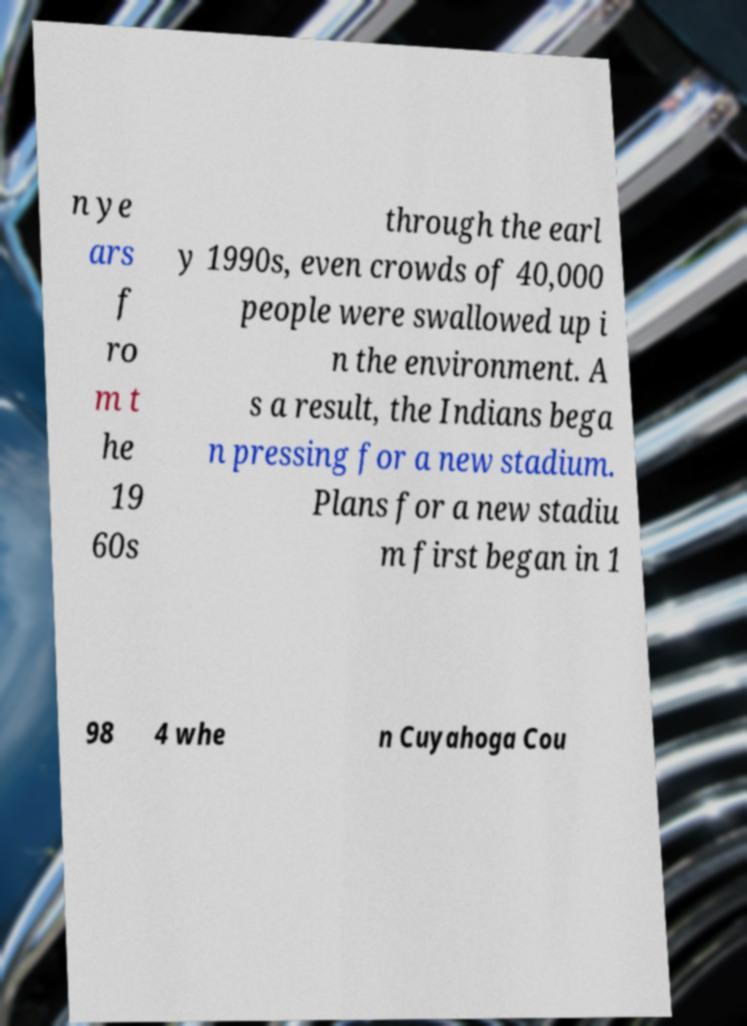What messages or text are displayed in this image? I need them in a readable, typed format. n ye ars f ro m t he 19 60s through the earl y 1990s, even crowds of 40,000 people were swallowed up i n the environment. A s a result, the Indians bega n pressing for a new stadium. Plans for a new stadiu m first began in 1 98 4 whe n Cuyahoga Cou 